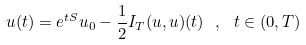<formula> <loc_0><loc_0><loc_500><loc_500>u ( t ) = e ^ { t S } u _ { 0 } - \frac { 1 } { 2 } I _ { T } ( u , u ) ( t ) \ , \ t \in ( 0 , T )</formula> 